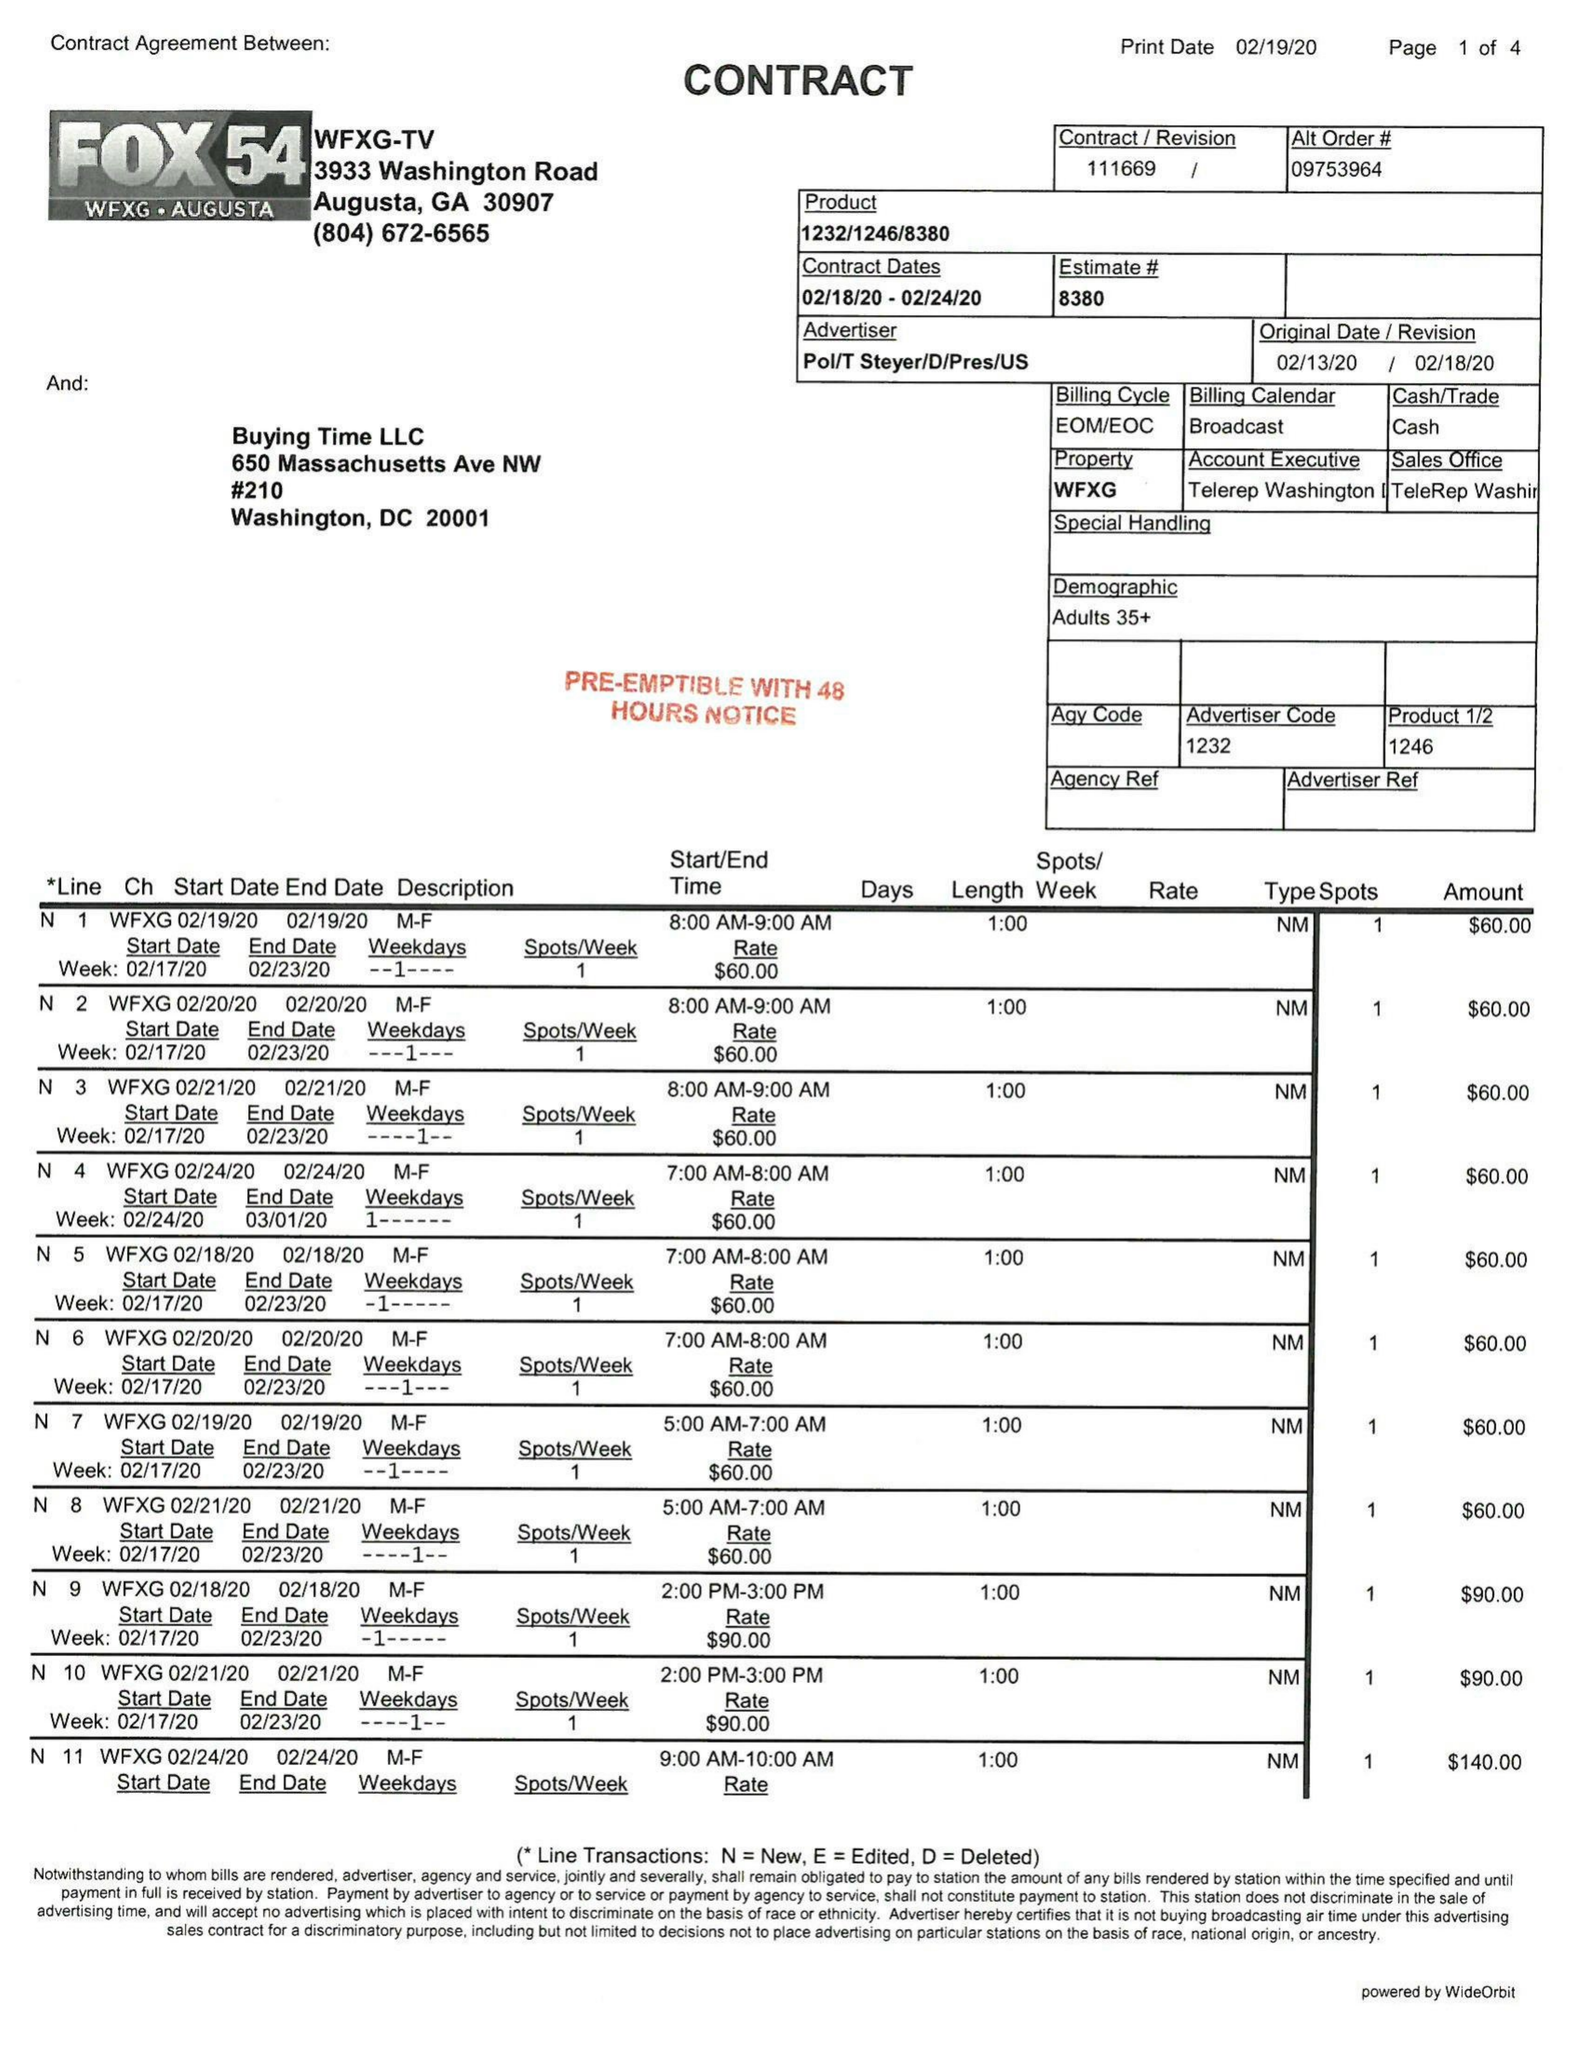What is the value for the advertiser?
Answer the question using a single word or phrase. POL/TSTEYER/D/PRES/US 